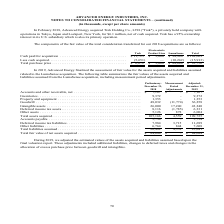According to Advanced Energy's financial document, What is Trek's ownership interest in its U.S. subsidiary? According to the financial document, 95%. The relevant text states: "for $6.1 million, net of cash acquired. Trek has a 95% ownership interest in its U.S. subsidiary which is also its primary operation...." Also, What was the fair value of cash paid for acquisition of Trek? According to the financial document, $11,723 (in thousands). The relevant text states: "ine LumaSense Total Cash paid for acquisition . $ 11,723 $ 3,000 $ 94,946 $ 109,669..." Also, What was the fair value of cash paid for acquisition of Lumasense? According to the financial document, $94,946 (in thousands). The relevant text states: "al Cash paid for acquisition . $ 11,723 $ 3,000 $ 94,946 $ 109,669..." Also, can you calculate: What was the difference in the fair value of cash paid for acquisition between Trek and Electrostatic Product Line? Based on the calculation: $11,723-$3,000, the result is 8723 (in thousands). This is based on the information: "ine LumaSense Total Cash paid for acquisition . $ 11,723 $ 3,000 $ 94,946 $ 109,669 ense Total Cash paid for acquisition . $ 11,723 $ 3,000 $ 94,946 $ 109,669..." The key data points involved are: 11,723, 3,000. Also, can you calculate: What is the sum of the two highest total purchase prices? Based on the calculation: $84,684+$6,072, the result is 90756 (in thousands). This is based on the information: "651) — (10,262) (15,913) Total purchase price . $ 6,072 $ 3,000 $ 84,684 $ 93,756 (15,913) Total purchase price . $ 6,072 $ 3,000 $ 84,684 $ 93,756..." The key data points involved are: 6,072, 84,684. Also, can you calculate: What is the average total purchase price amongst the three companies? To answer this question, I need to perform calculations using the financial data. The calculation is: ($6,072+$3,000+$84,684)/3, which equals 31252 (in thousands). This is based on the information: "ense Total Cash paid for acquisition . $ 11,723 $ 3,000 $ 94,946 $ 109,669 (15,913) Total purchase price . $ 6,072 $ 3,000 $ 84,684 $ 93,756 651) — (10,262) (15,913) Total purchase price . $ 6,072 $ 3..." The key data points involved are: 3,000, 6,072, 84,684. 